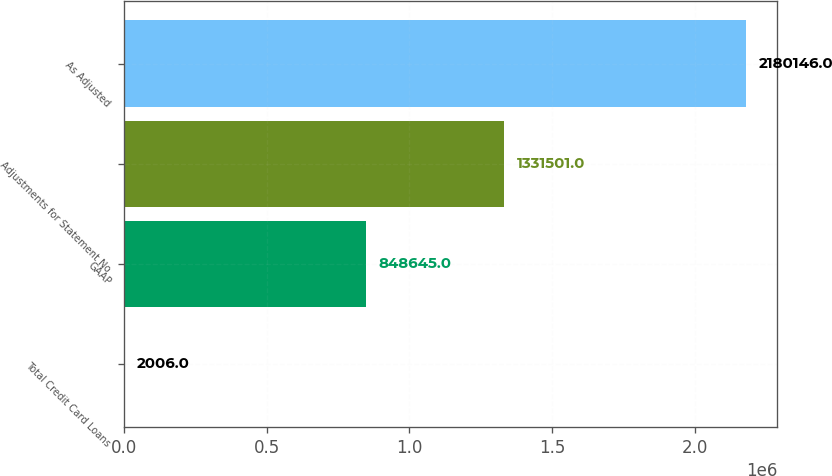<chart> <loc_0><loc_0><loc_500><loc_500><bar_chart><fcel>Total Credit Card Loans<fcel>GAAP<fcel>Adjustments for Statement No<fcel>As Adjusted<nl><fcel>2006<fcel>848645<fcel>1.3315e+06<fcel>2.18015e+06<nl></chart> 